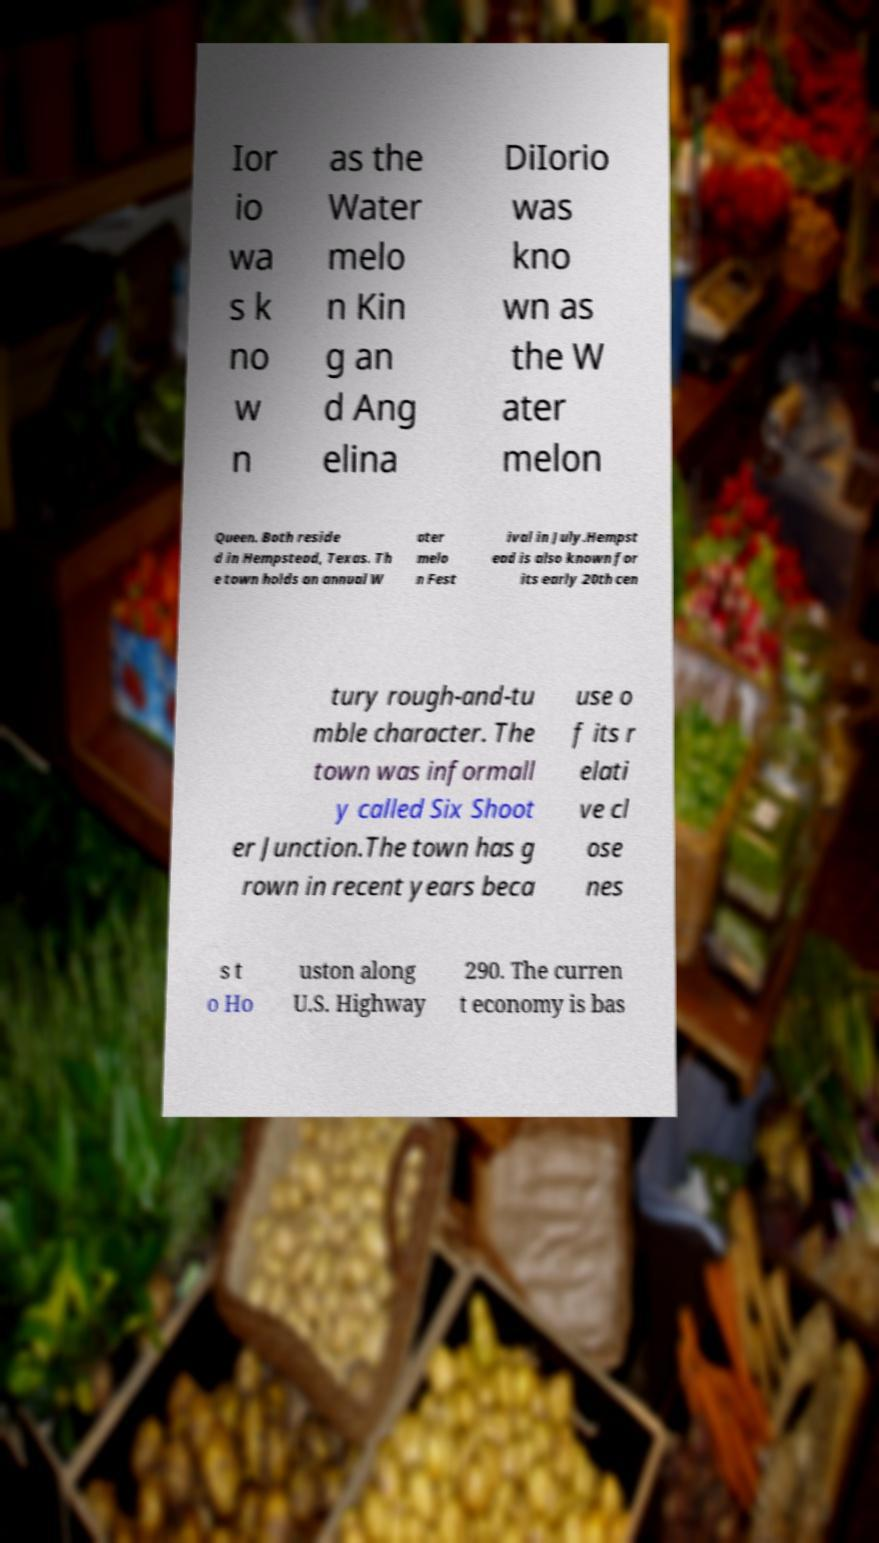I need the written content from this picture converted into text. Can you do that? Ior io wa s k no w n as the Water melo n Kin g an d Ang elina DiIorio was kno wn as the W ater melon Queen. Both reside d in Hempstead, Texas. Th e town holds an annual W ater melo n Fest ival in July.Hempst ead is also known for its early 20th cen tury rough-and-tu mble character. The town was informall y called Six Shoot er Junction.The town has g rown in recent years beca use o f its r elati ve cl ose nes s t o Ho uston along U.S. Highway 290. The curren t economy is bas 